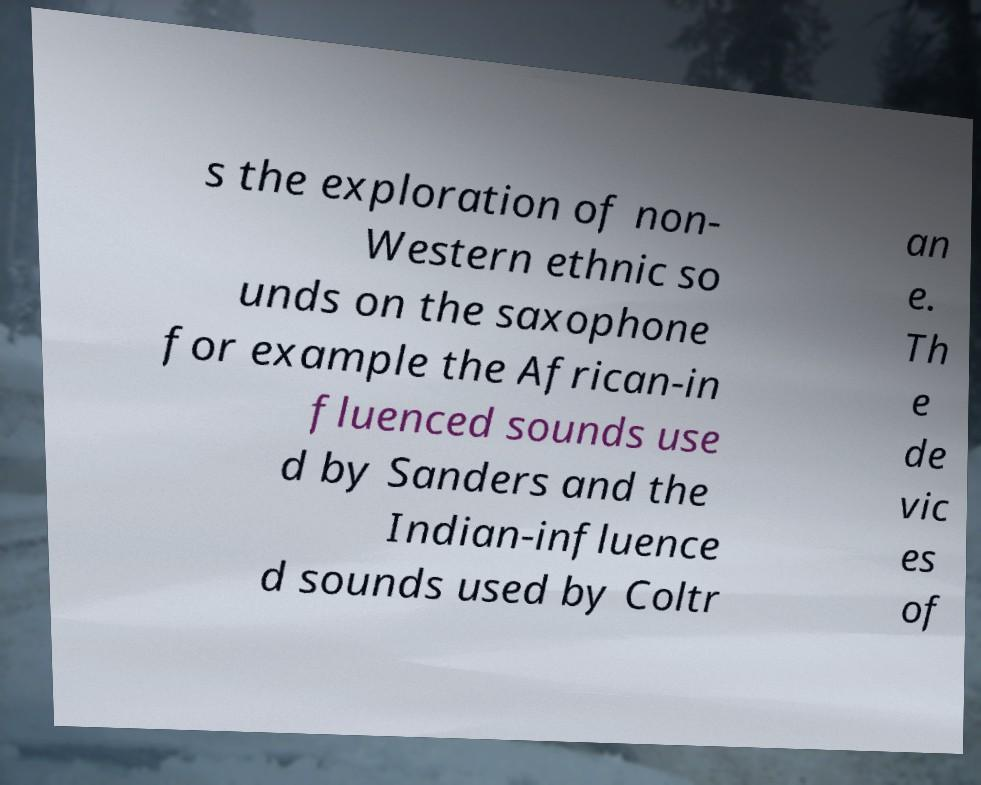Could you extract and type out the text from this image? s the exploration of non- Western ethnic so unds on the saxophone for example the African-in fluenced sounds use d by Sanders and the Indian-influence d sounds used by Coltr an e. Th e de vic es of 